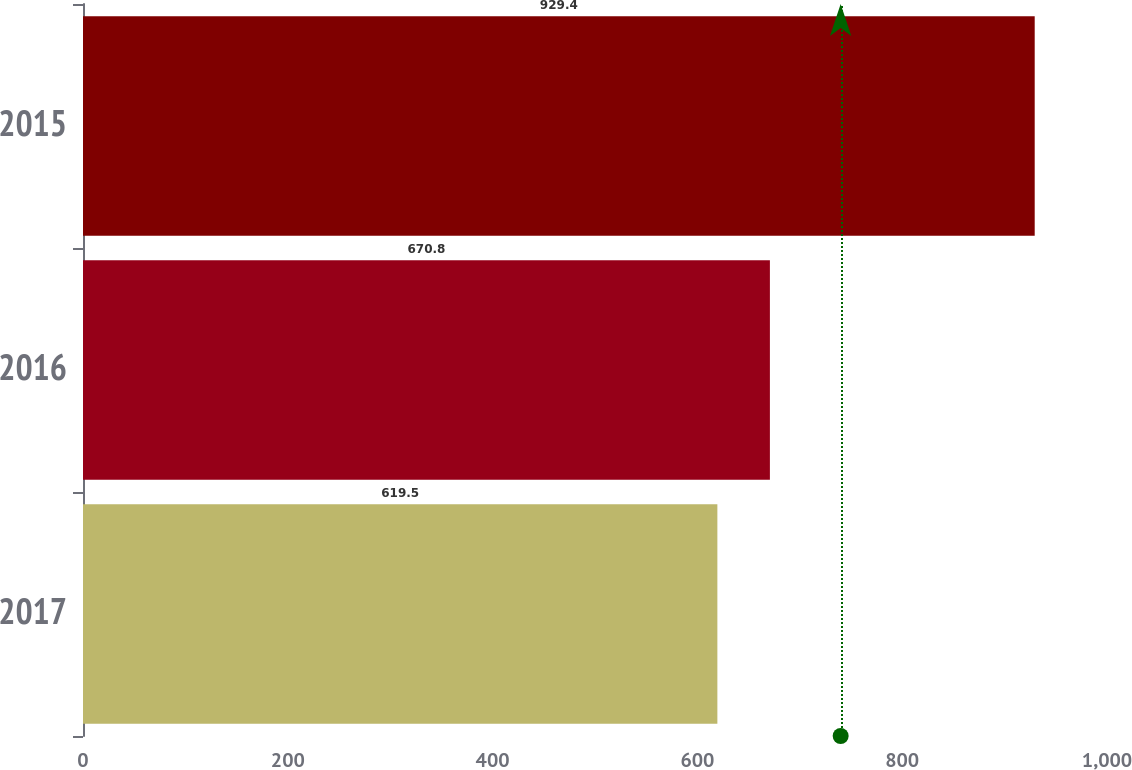<chart> <loc_0><loc_0><loc_500><loc_500><bar_chart><fcel>2017<fcel>2016<fcel>2015<nl><fcel>619.5<fcel>670.8<fcel>929.4<nl></chart> 